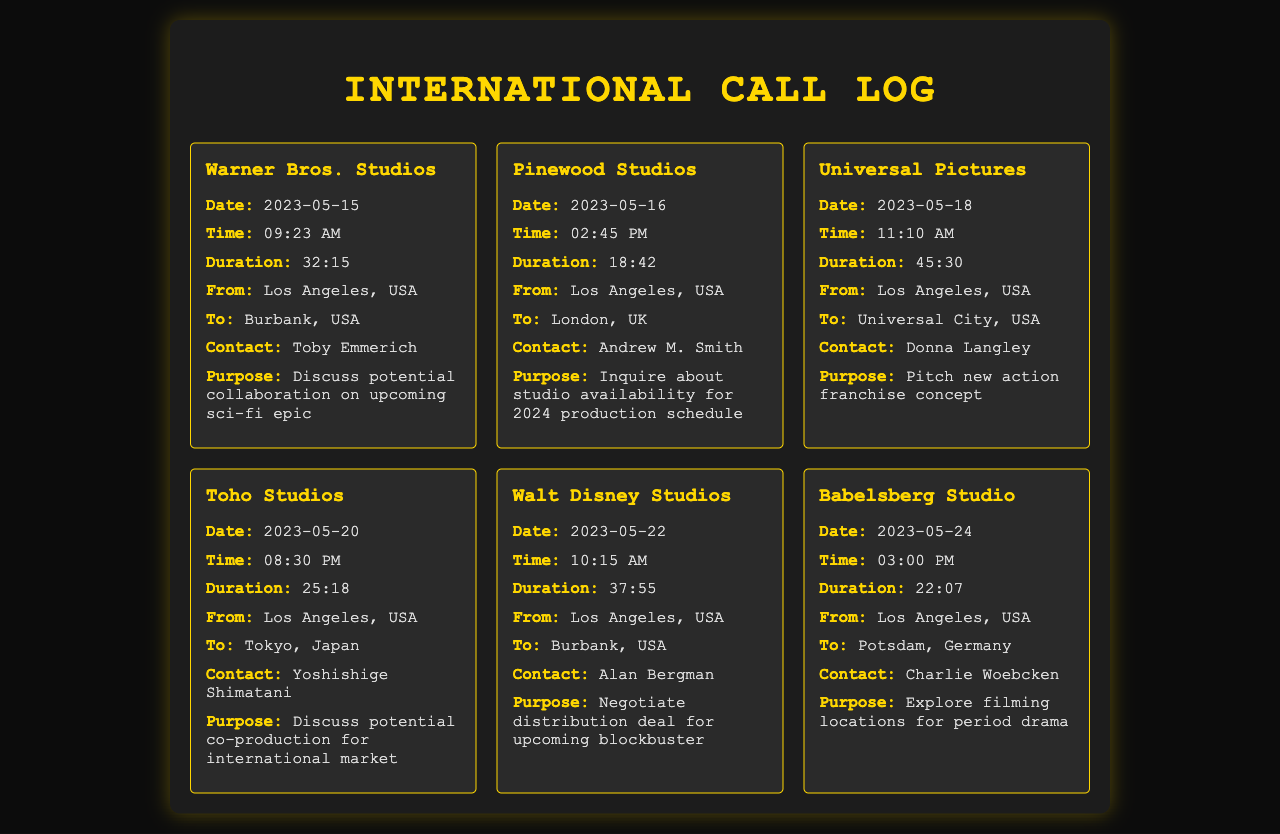what is the date of the call to Toho Studios? The call to Toho Studios took place on May 20, 2023.
Answer: May 20, 2023 who was contacted at Pinewood Studios? The contact at Pinewood Studios was Andrew M. Smith.
Answer: Andrew M. Smith what was the duration of the call to Universal Pictures? The call to Universal Pictures lasted for 45 minutes and 30 seconds.
Answer: 45:30 which studio was contacted for a negotiation of a distribution deal? The call to negotiate a distribution deal was with Walt Disney Studios.
Answer: Walt Disney Studios what was the purpose of the call to Babelsberg Studio? The purpose of the call to Babelsberg Studio was to explore filming locations for a period drama.
Answer: Explore filming locations for period drama how many calls were made in total as per the record? There are a total of six calls recorded in the document.
Answer: Six 